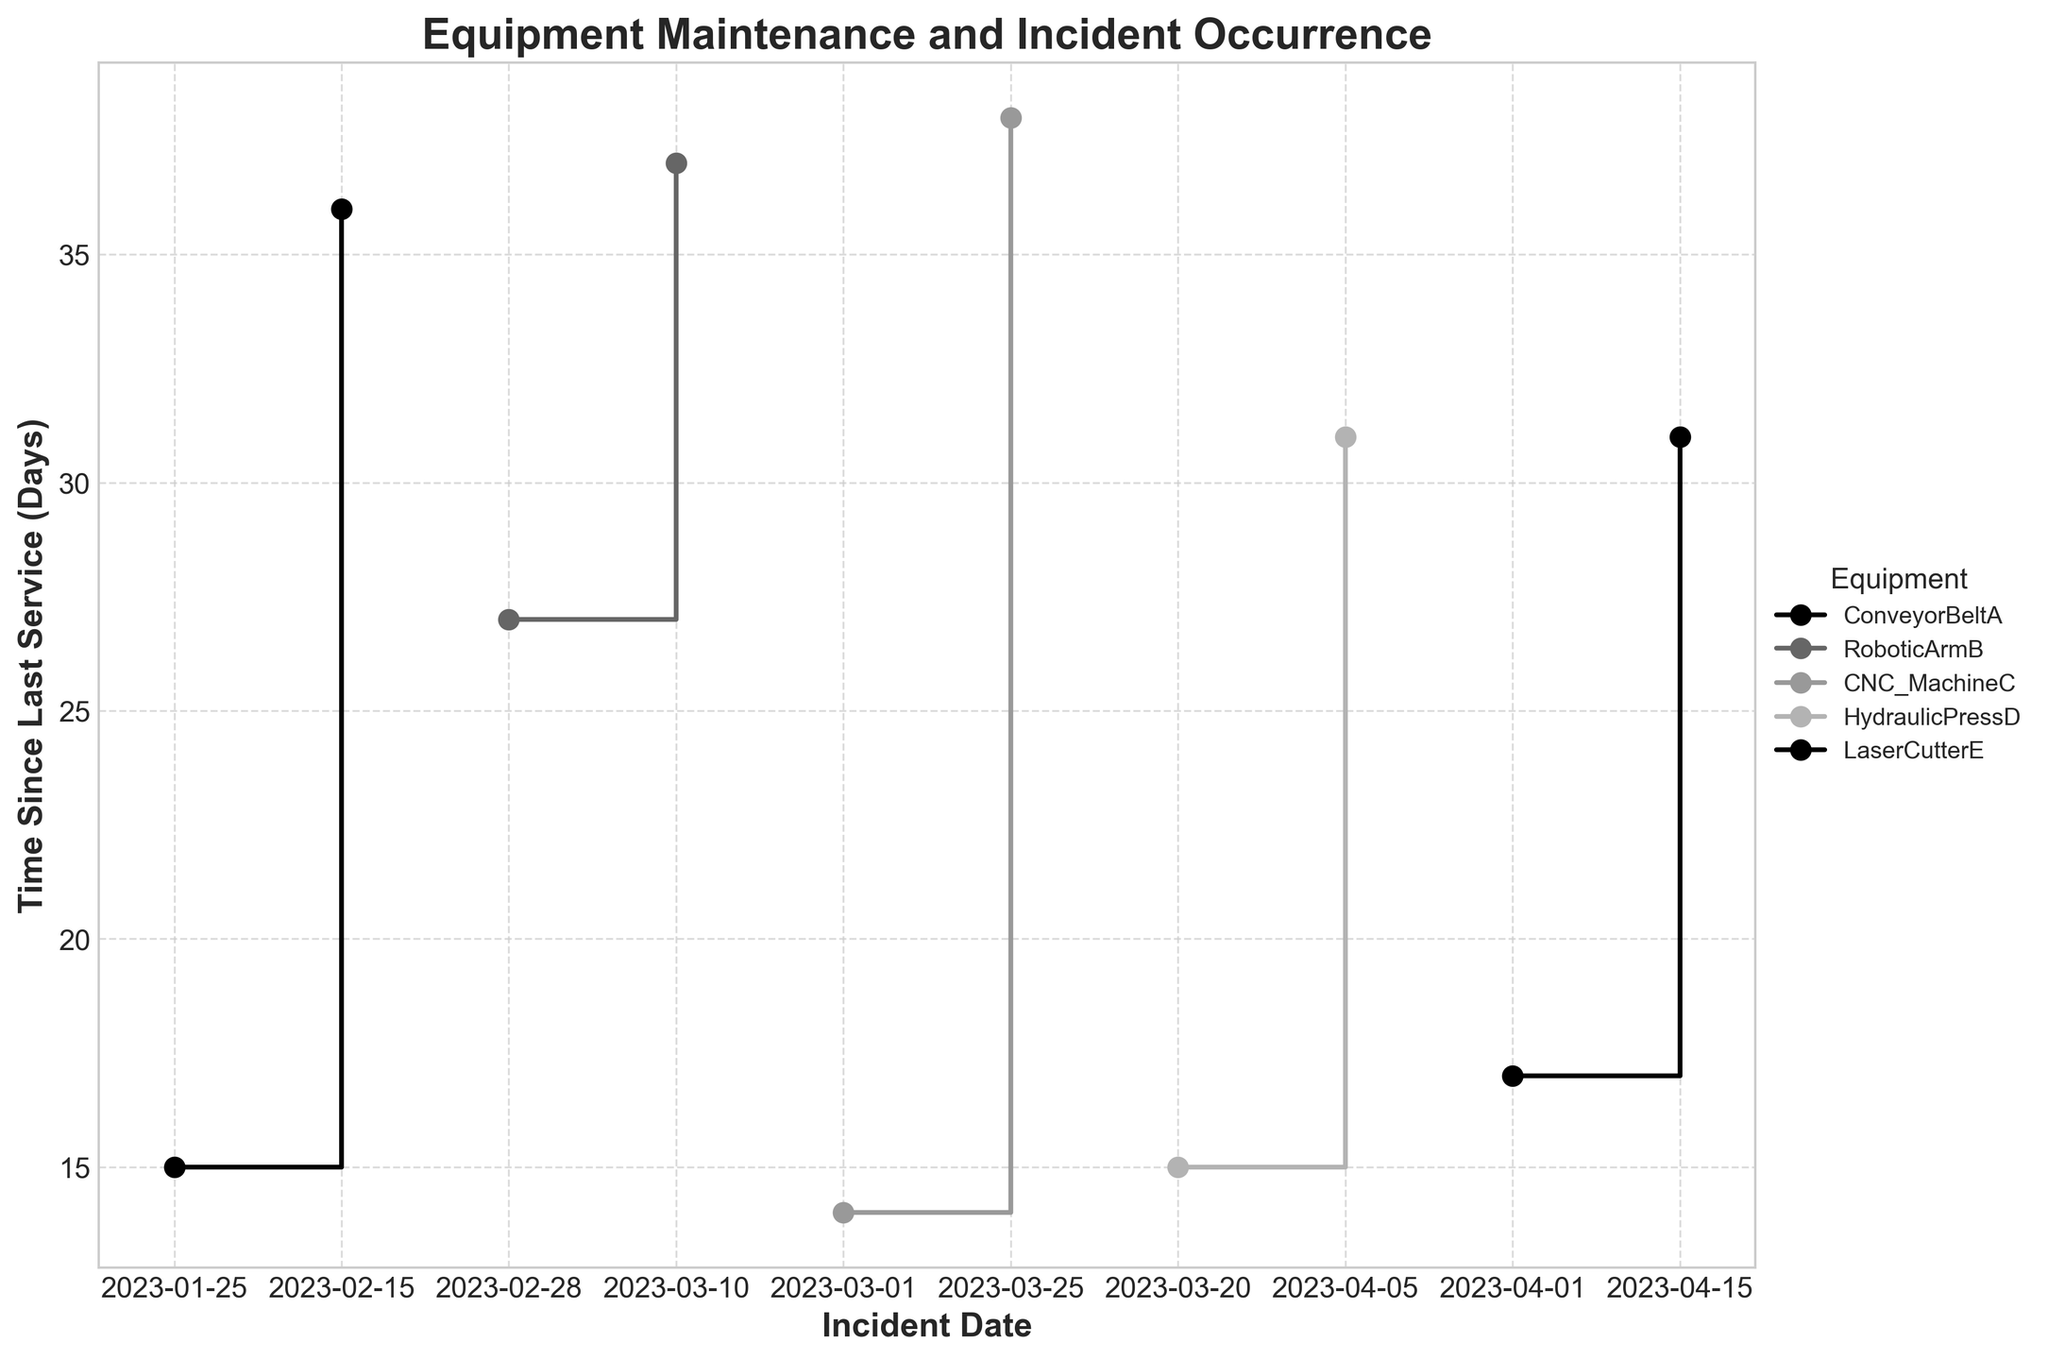What's the title of the plot? The title is displayed prominently at the top of the figure. It reads "Equipment Maintenance and Incident Occurrence," indicating the theme of the plot.
Answer: Equipment Maintenance and Incident Occurrence What values are represented on the x-axis and y-axis? The labels on the x-axis and y-axis are clearly marked. The x-axis represents "Incident Date" while the y-axis indicates "Time Since Last Service (Days)."
Answer: Incident Date, Time Since Last Service (Days) For which date range is the time since last service highest for CNC_MachineC? By examining the stair-steps for CNC_MachineC, you can observe which incident date range corresponds to the highest peak on the y-axis. The highest value for CNC_MachineC occurs around March 25, 2023, where the time since last service is 38 days.
Answer: Around March 25, 2023 Which equipment experiences incidents more frequently, ConveyorBeltA or HydraulicPressD? Compare the number of data points (steps) on the plot for each equipment. ConveyorBeltA has incidents on January 25, February 15 while HydraulicPressD has incidents on March 20 and April 5. Both pieces of equipment experience incidents twice, so they experience incidents equally frequently.
Answer: Equally frequent What’s the average time since last service for RoboticArmB? Calculate the mean of "Time Since Last Service (Days)" for incidents related to RoboticArmB. The two values are 27 and 37 days. The average is (27+37)/2 = 32 days.
Answer: 32 days Which piece of equipment had the shortest time since last service when the first incident occurred? Identify the first incident for each piece of equipment by observing the leftmost point (first stair-step) for each curve. Compare the "Time Since Last Service (Days)" for these points. The shortest time is 14 days for CNC_MachineC on March 1, 2023.
Answer: CNC_MachineC on March 1, 2023 What is the difference in time since last service for the two incidents of LaserCutterE? Subtract the values for LaserCutterE’s incidents, which are 31 days and 17 days. The difference is 31 - 17 = 14 days.
Answer: 14 days At what incident date did ConveyorBeltA have the highest time since last service? Trace through the steps specific to ConveyorBeltA (marked and labeled) to find the highest value on the y-axis "Time Since Last Service (Days)" and note the corresponding "Incident Date". The highest value of 36 days occurred on February 15, 2023.
Answer: February 15, 2023 How many unique pieces of equipment are represented in the plot? The legend lists each piece of equipment, which corresponds to distinct lines in the plot. Count these unique entries. There are 5 unique pieces of equipment represented.
Answer: 5 